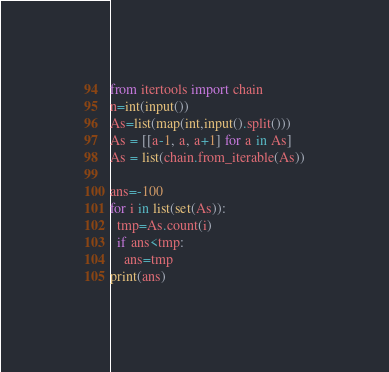<code> <loc_0><loc_0><loc_500><loc_500><_Python_>from itertools import chain
n=int(input())
As=list(map(int,input().split()))
As = [[a-1, a, a+1] for a in As]
As = list(chain.from_iterable(As))

ans=-100
for i in list(set(As)):
  tmp=As.count(i)
  if ans<tmp:
    ans=tmp
print(ans)</code> 